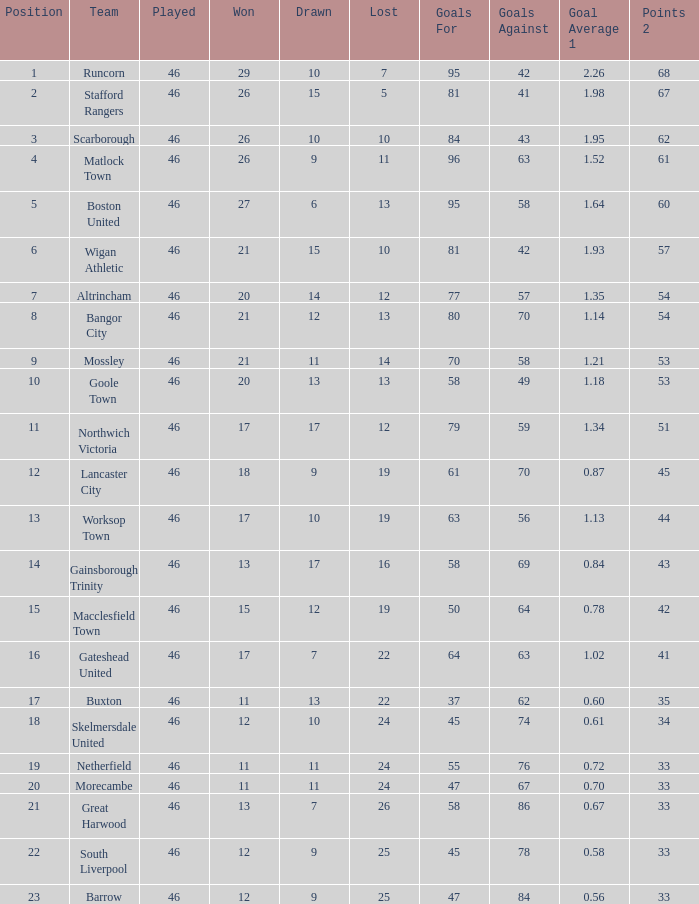What is the highest position of the Bangor City team? 8.0. 